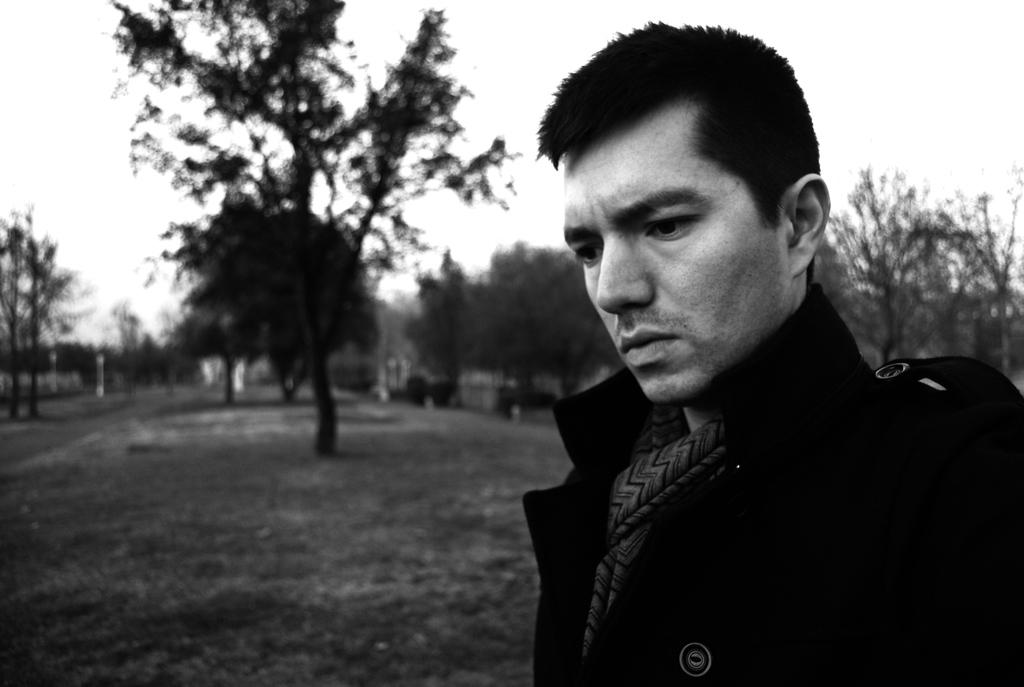What is the main subject in the foreground of the image? There is a person in the foreground of the image. What is the person doing in the image? The person is looking at something. What can be seen in the background of the image? There are trees in the background of the image. What type of sweater is the person wearing in the image? There is no information about the person's clothing in the image, so it cannot be determined if they are wearing a sweater. 